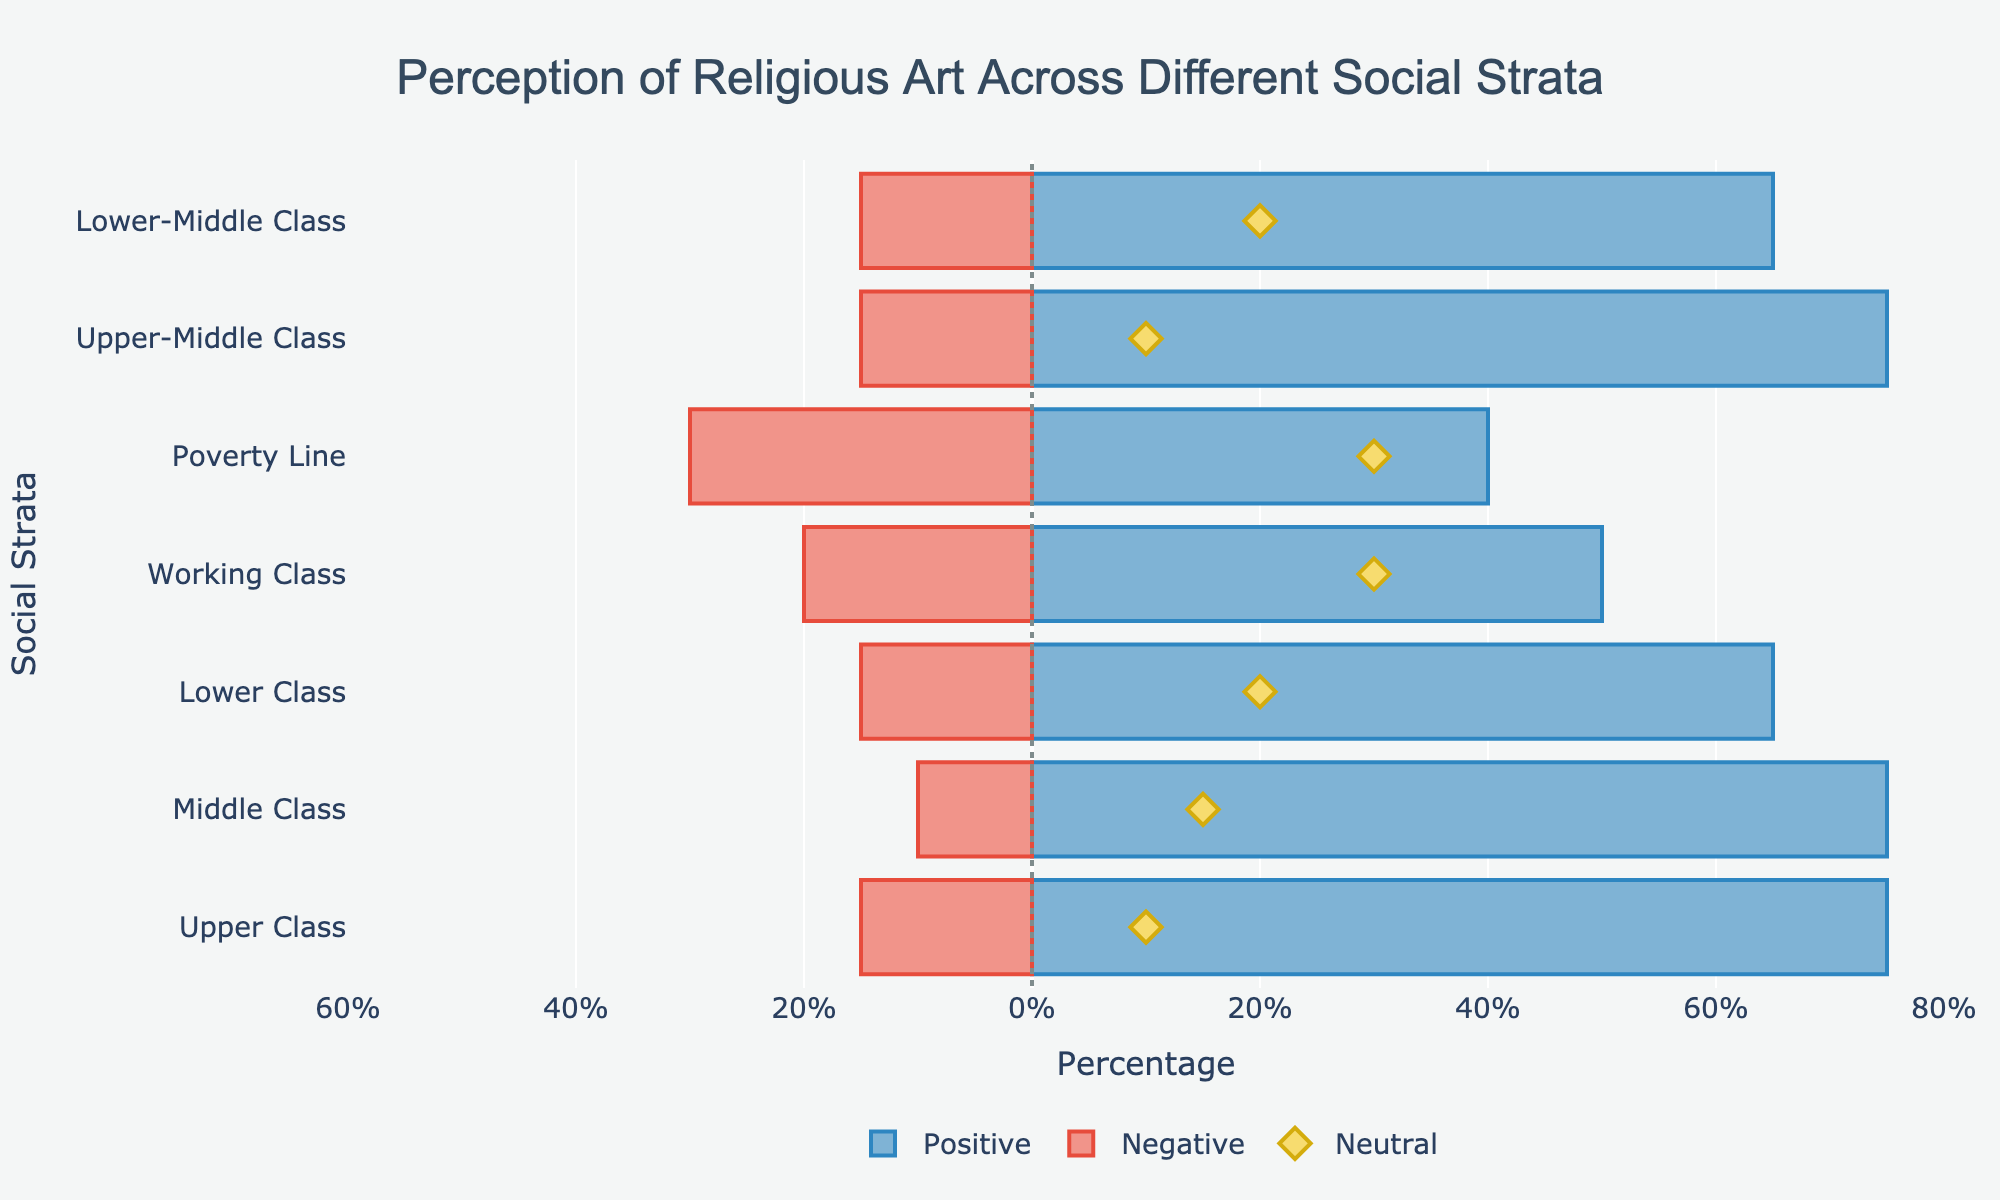What social strata has the highest positive perception of religious art? To determine which social strata has the highest positive perception, sum the 'Highly Positive' and 'Positive' values for each group and compare them. The Upper Class has the highest positive perception with a sum of 55 + 20 = 75.
Answer: Upper Class Which social strata has the lowest negative perception of religious art? To find the lowest negative perception, sum the 'Negative' and 'Highly Negative' values for each group. The Middle Class has the lowest negative perception with a sum of 5 + 5 = 10.
Answer: Middle Class How does the neutral perception of the Upper-Middle Class compare to the Lower-Middle Class? Compare the 'Neutral' values for both social strata. The Upper-Middle Class has 10% neutral perception while the Lower-Middle Class has 20%.
Answer: Upper-Middle Class has a lower neutral perception Which social strata shows the most balanced perception between positive and negative perceptions? To determine balance, compare the absolute difference between the total positive and negative perceptions for each social strata. The Working Class has similar positive (25 + 25 = 50) and negative (10 + 10 = 20) values, indicating a more balanced perception.
Answer: Working Class Are there any social strata with equal values for neutral and one of the other perceptions? Yes, the Poverty Line has equal neutral and positive (15 + 25 = 40) perceptions.
Answer: Poverty Line For which social strata is the difference between positive and negative perceptions the greatest? First, calculate the difference between positive and negative perceptions for each stratum. The Upper Class has the greatest difference: 75 (positive) - 15 (negative) = 60.
Answer: Upper Class Which social strata has the closest percentage of neutral perception to the Upper Class? Find the 'Neutral' value of Upper Class (10%) and compare it to others. The Upper-Middle Class also has 10% neutral perception, which is closest.
Answer: Upper-Middle Class What is the total percentage of neutral perception across all social strata? Sum the 'Neutral' values of all social strata: 10 + 15 + 20 + 30 + 30 + 10 + 20 = 135.
Answer: 135% Between the Middle Class and Lower Class, which has a higher neutral perception of religious art? Compare the 'Neutral' values: Middle Class has 15% while Lower Class has 20%.
Answer: Lower Class How does the positive perception of the Upper-Middle Class compare to the Lower Class? Calculate the total positive perception for both: Upper-Middle = 50 + 25 = 75, Lower = 30 + 35 = 65. The Upper-Middle Class has a higher positive perception.
Answer: Upper-Middle Class has a higher positive perception 